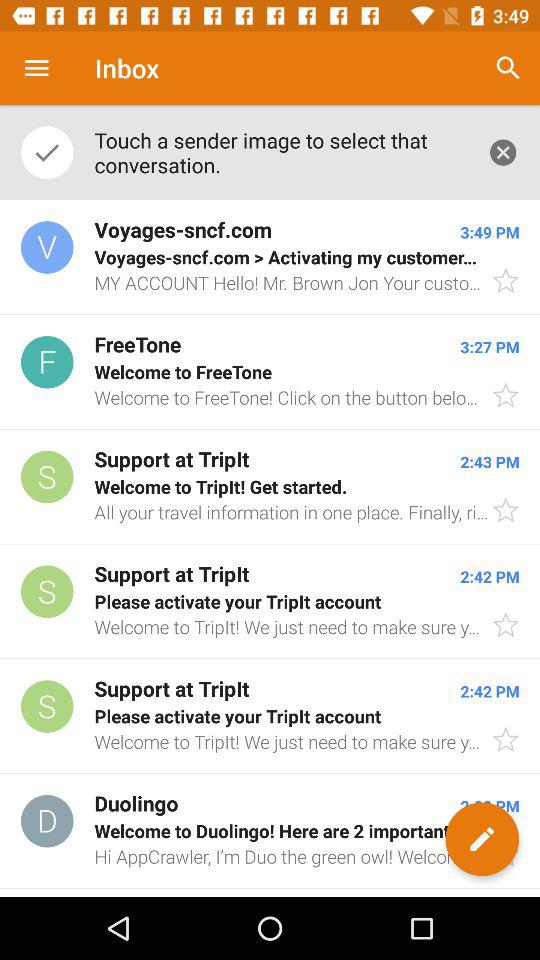When did the mail arrive from FreeTone? The mail arrived at 3:27 PM. 